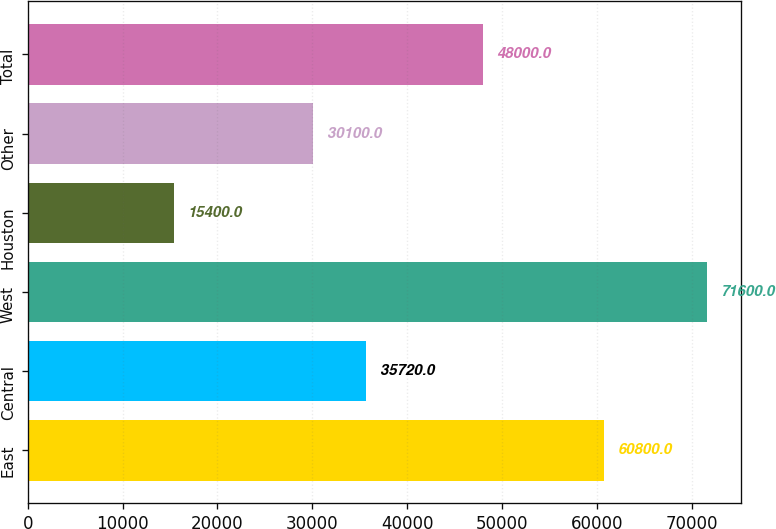<chart> <loc_0><loc_0><loc_500><loc_500><bar_chart><fcel>East<fcel>Central<fcel>West<fcel>Houston<fcel>Other<fcel>Total<nl><fcel>60800<fcel>35720<fcel>71600<fcel>15400<fcel>30100<fcel>48000<nl></chart> 